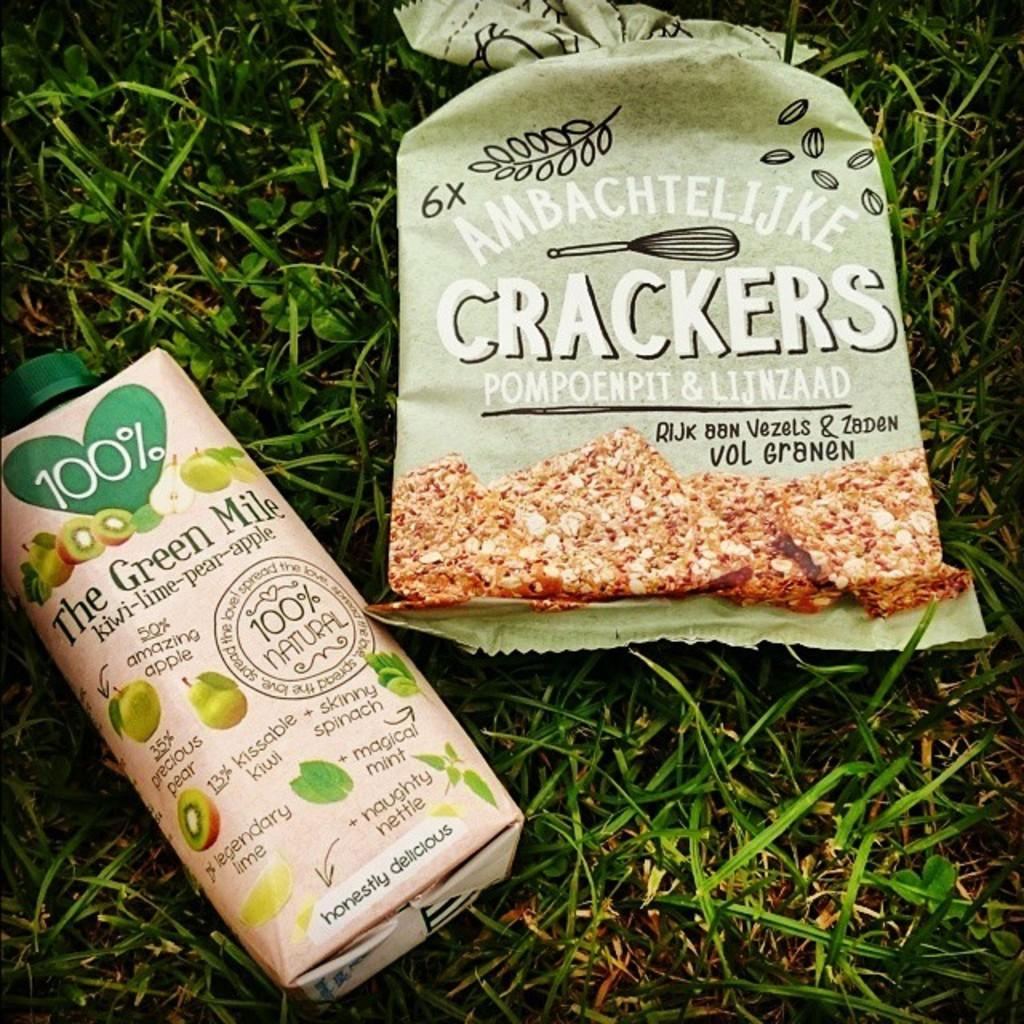<image>
Provide a brief description of the given image. Bag of Ambachtelije Crackers next to a drink called The Green Mile. 